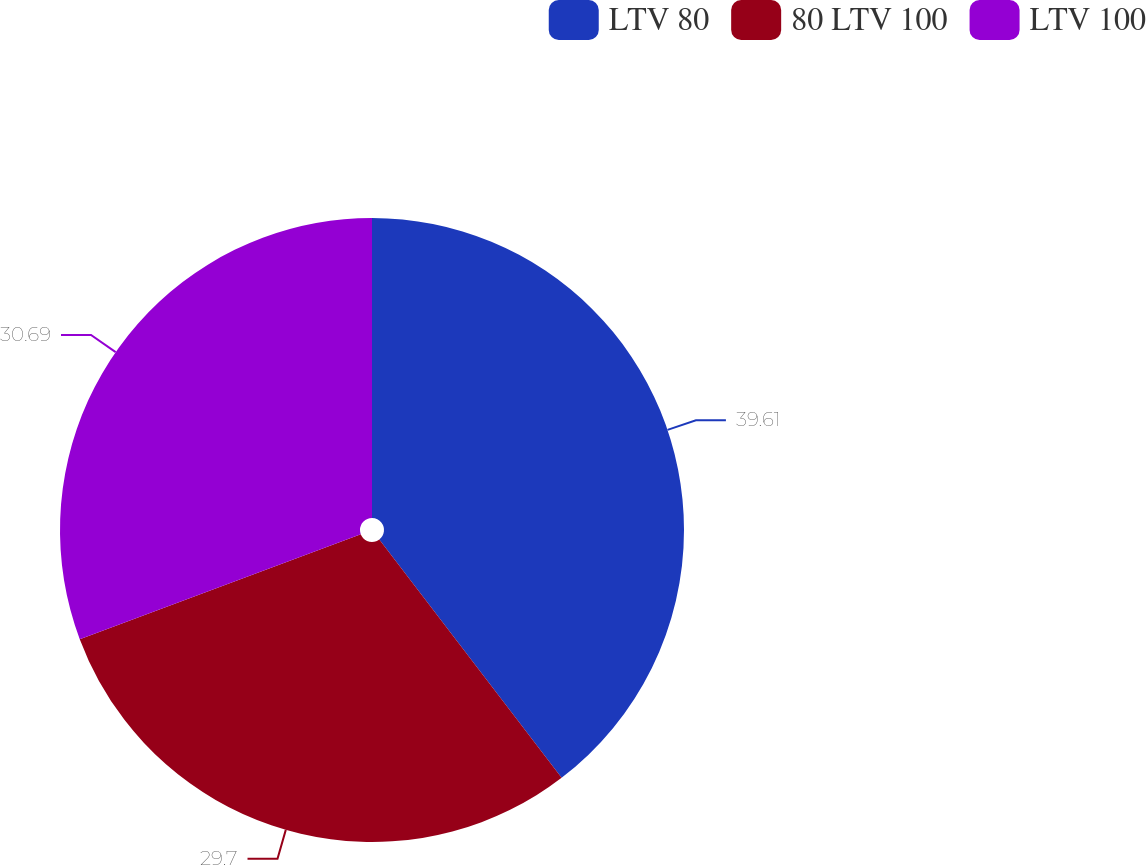Convert chart to OTSL. <chart><loc_0><loc_0><loc_500><loc_500><pie_chart><fcel>LTV 80<fcel>80 LTV 100<fcel>LTV 100<nl><fcel>39.6%<fcel>29.7%<fcel>30.69%<nl></chart> 